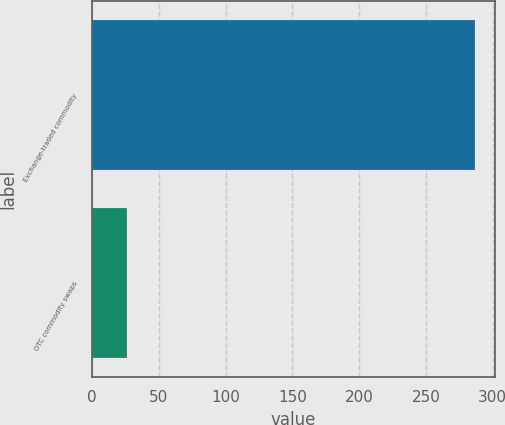Convert chart to OTSL. <chart><loc_0><loc_0><loc_500><loc_500><bar_chart><fcel>Exchange-traded commodity<fcel>OTC commodity swaps<nl><fcel>287<fcel>26<nl></chart> 